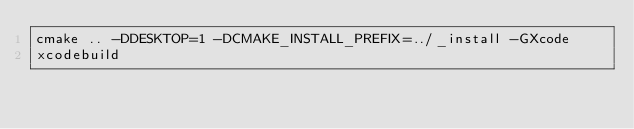<code> <loc_0><loc_0><loc_500><loc_500><_Bash_>cmake .. -DDESKTOP=1 -DCMAKE_INSTALL_PREFIX=../_install -GXcode
xcodebuild</code> 